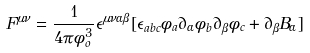<formula> <loc_0><loc_0><loc_500><loc_500>F ^ { \mu \nu } = \frac { 1 } { 4 \pi \phi _ { o } ^ { 3 } } \epsilon ^ { \mu \nu \alpha \beta } [ \epsilon _ { a b c } \phi _ { a } \partial _ { \alpha } \phi _ { b } \partial _ { \beta } \phi _ { c } + \partial _ { \beta } B _ { \alpha } ]</formula> 